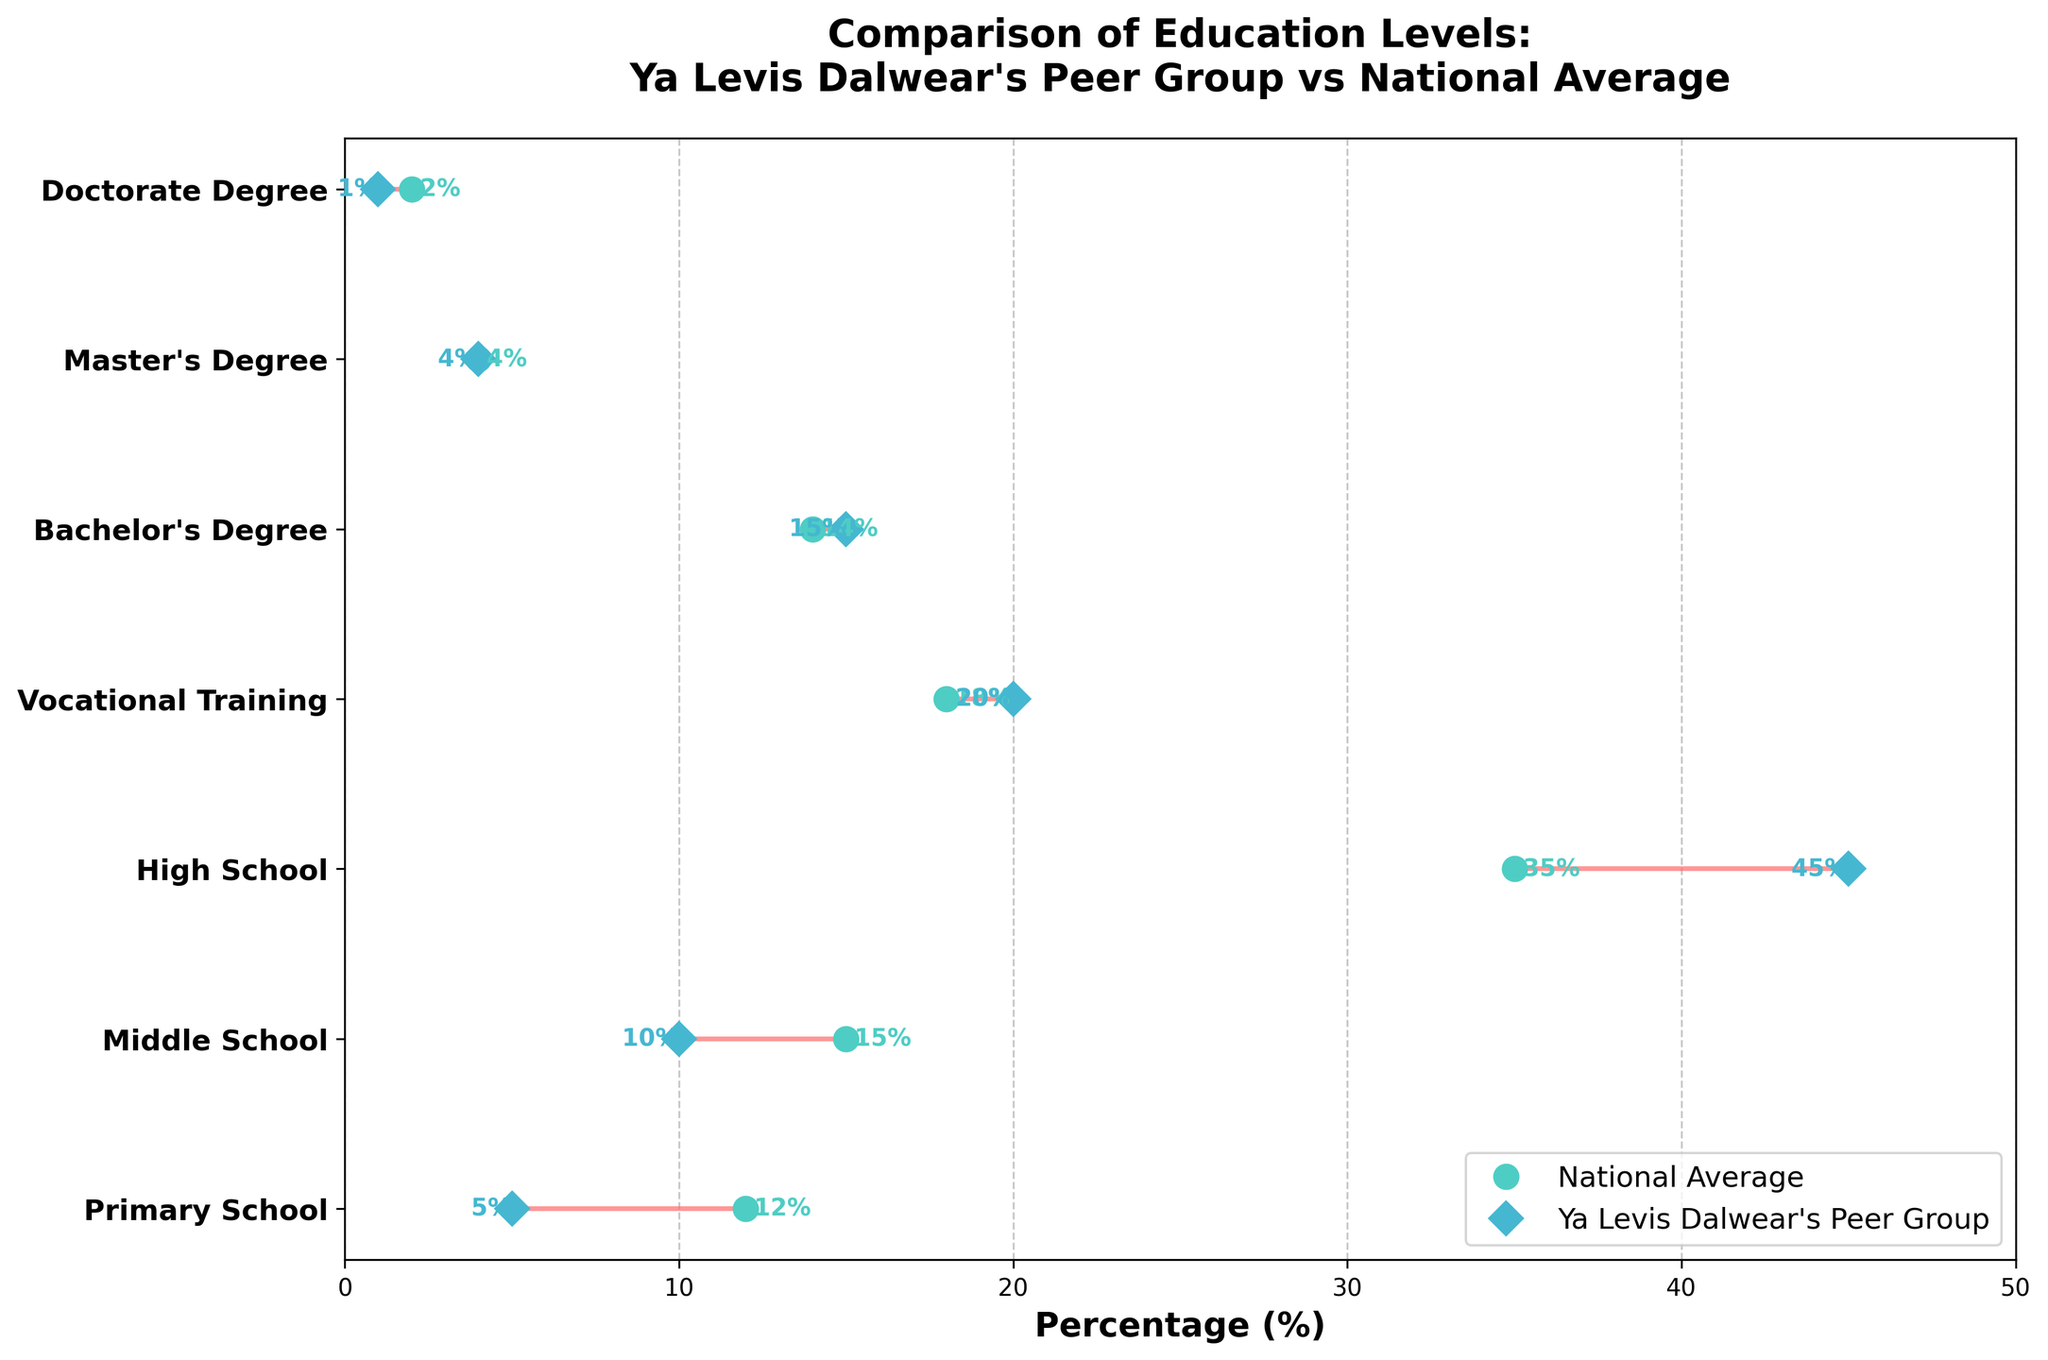What is the percentage of Bachelor's Degree holders in Ya Levis Dalwear's peer group? According to the plot, the percentage of Bachelor's Degree holders in Ya Levis Dalwear's peer group is marked by a blue diamond at the level labeled "Bachelor's Degree."
Answer: 15% How does the percentage of Master’s Degree holders in Ya Levis Dalwear’s peer group compare to the national average? Look at the level labeled "Master's Degree." Both the blue diamond (Ya Levis Dalwear's peer group) and the green circle (national average) are marked at 4%.
Answer: They are equal Which education level shows the largest difference between Ya Levis Dalwear’s peer group and the national average? Compare the distances between the blue diamonds and green circles for each education level. The "Primary School" level has the largest gap, with 5% for Ya Levis Dalwear’s peer group and 12% for the national average.
Answer: Primary School What is the combined percentage of High School and Vocational Training in Ya Levis Dalwear’s peer group? Add the percentages from the levels labeled "High School" and "Vocational Training" in Ya Levis Dalwear’s peer group: 45% + 20%.
Answer: 65% Are there more people with a Doctorate Degree in the national average or in Ya Levis Dalwear’s peer group? Look at the levels labeled "Doctorate Degree." The green circle (national average) is at 2% and the blue diamond (peer group) is at 1%.
Answer: National average Which education level has the smallest percentage difference between Ya Levis Dalwear’s peer group and the national average? Compare the percentages for each education level. The "Master’s Degree" level shows no difference as both percentages are 4%. Thus, it has the smallest percentage difference, which is 0%.
Answer: Master’s Degree What is the average percentage of Middle School and Vocational Training for the national average? Add the percentages for "Middle School" and "Vocational Training" from the national average and divide by 2: (15% + 18%) / 2.
Answer: 16.5% Which level has a higher percentage in Ya Levis Dalwear’s peer group compared to the national average, but less than 10% difference? Compare the education levels and their differences. "High School" has a 10% higher percentage in the peer group compared to the national average (45% vs. 35%). "Vocational Training" has a 2% higher percentage (20% vs. 18%). "Bachelor’s Degree" has a 1% higher percentage (15% vs. 14%).
Answer: Vocational Training and Bachelor’s Degree How many education levels have a higher percentage in Ya Levis Dalwear’s peer group compared to the national average? Count the levels where the blue diamond is to the right of the green circle. These levels are "High School", "Vocational Training," and "Bachelor's Degree."
Answer: 3 For which education level is the national average exactly twice the percentage of Ya Levis Dalwear’s peer group? Compare the percentages. "Primary School" shows Ya Levis Dalwear’s peer group at 5% and the national average at 12%. "Doctorate Degree" shows Ya Levis Dalwear’s peer group at 1% and the national average at 2%. So, "Doctorate Degree" meets this criterion.
Answer: Doctorate Degree 